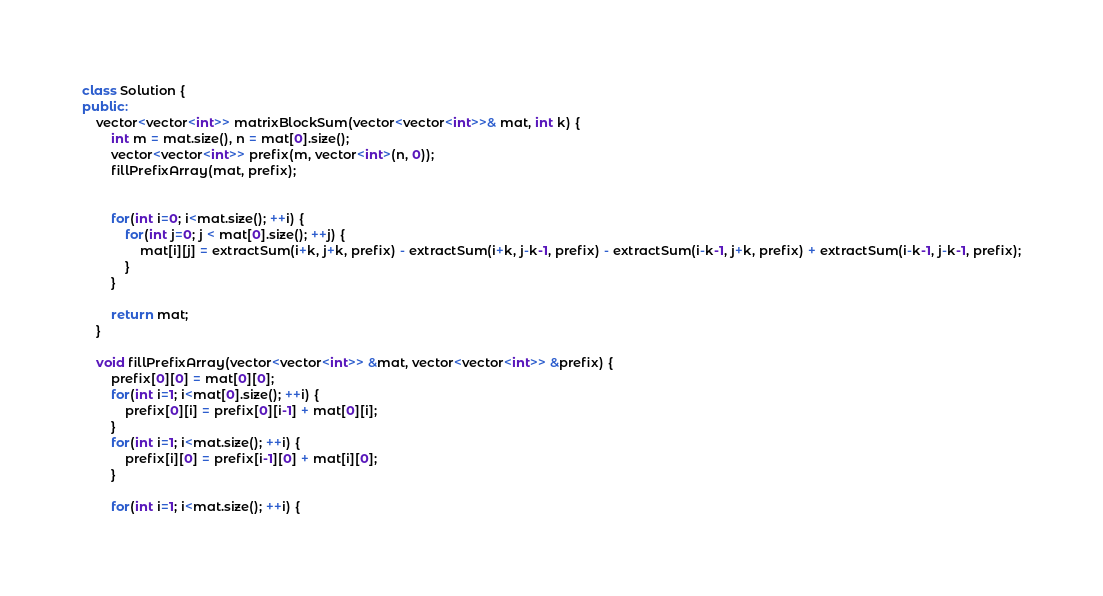<code> <loc_0><loc_0><loc_500><loc_500><_C++_>class Solution {
public:
    vector<vector<int>> matrixBlockSum(vector<vector<int>>& mat, int k) {
        int m = mat.size(), n = mat[0].size();
        vector<vector<int>> prefix(m, vector<int>(n, 0));
        fillPrefixArray(mat, prefix);
        
        
        for(int i=0; i<mat.size(); ++i) {
            for(int j=0; j < mat[0].size(); ++j) {
                mat[i][j] = extractSum(i+k, j+k, prefix) - extractSum(i+k, j-k-1, prefix) - extractSum(i-k-1, j+k, prefix) + extractSum(i-k-1, j-k-1, prefix);
            }
        }
        
        return mat;
    }
    
    void fillPrefixArray(vector<vector<int>> &mat, vector<vector<int>> &prefix) {
        prefix[0][0] = mat[0][0];
        for(int i=1; i<mat[0].size(); ++i) {
            prefix[0][i] = prefix[0][i-1] + mat[0][i];
        }
        for(int i=1; i<mat.size(); ++i) {
            prefix[i][0] = prefix[i-1][0] + mat[i][0];
        }
        
        for(int i=1; i<mat.size(); ++i) {</code> 